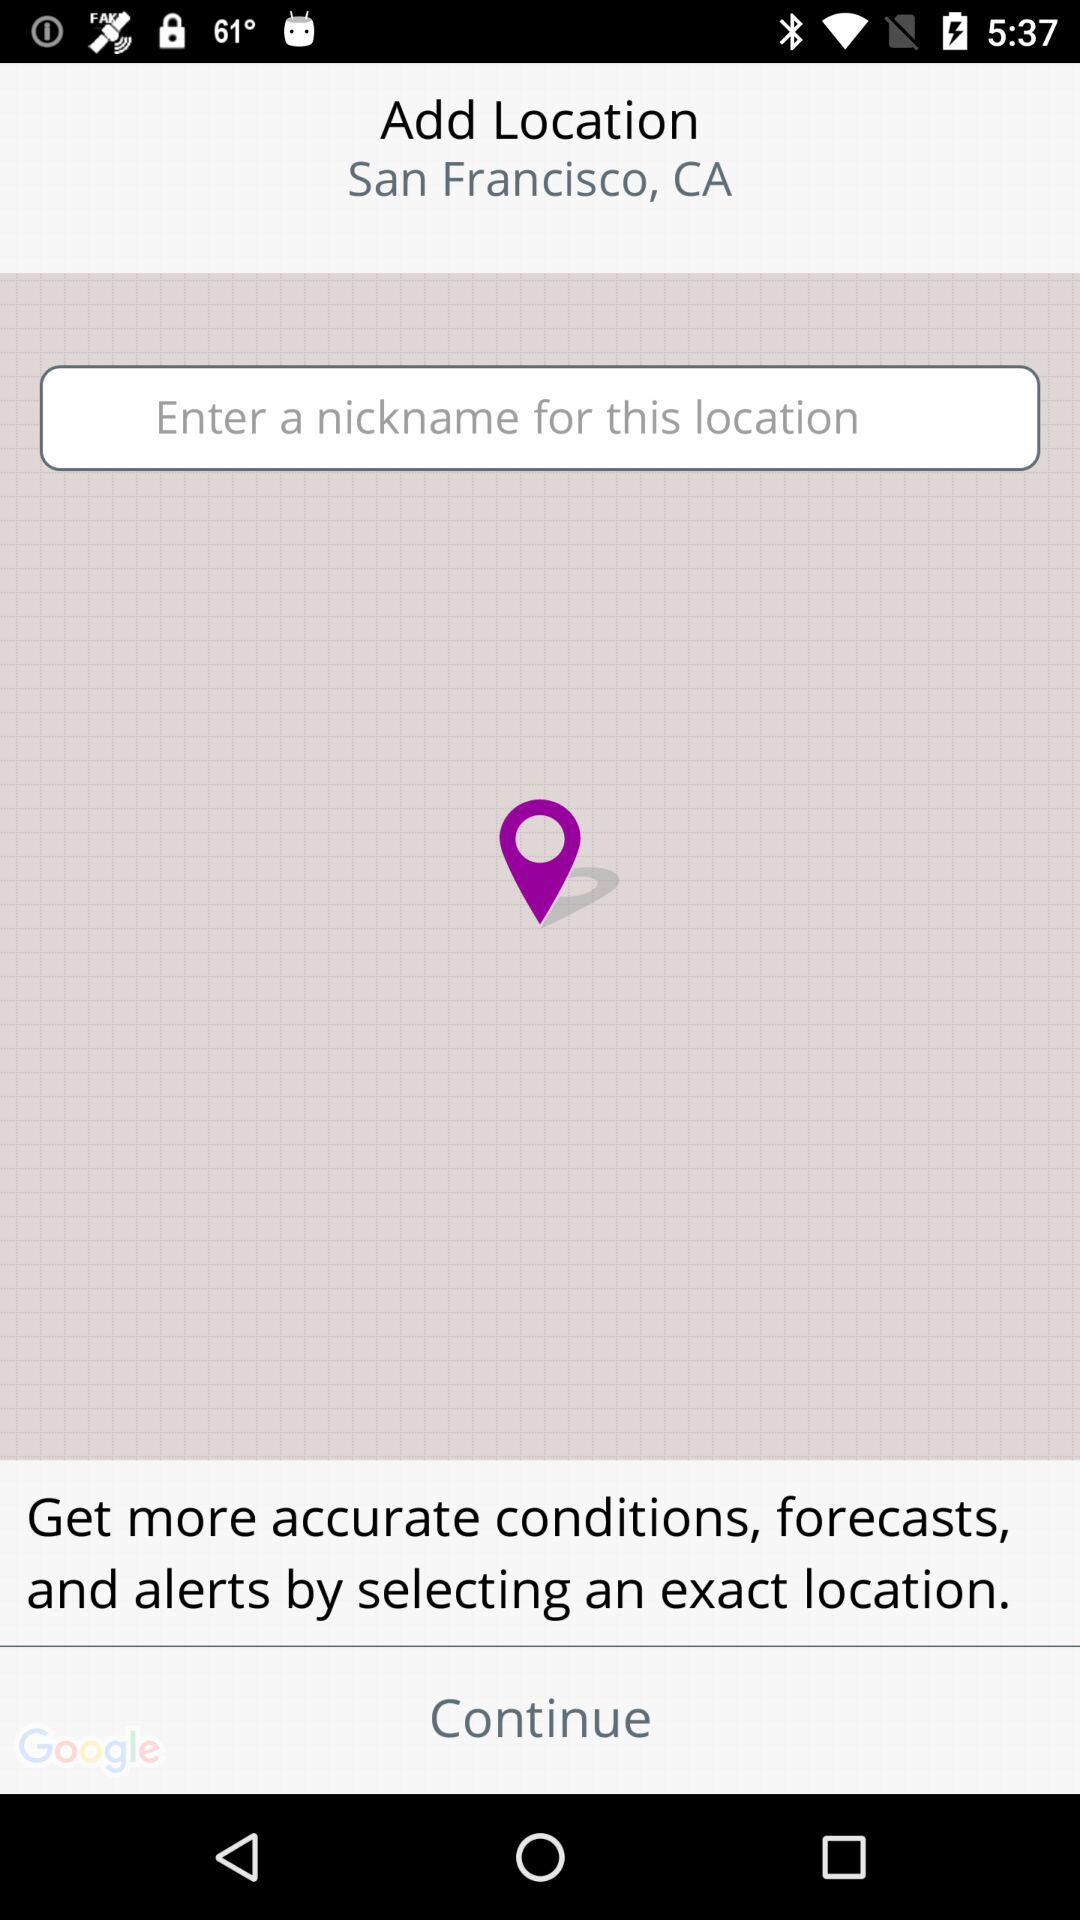What is the current location? The current location is San Francisco, CA. 